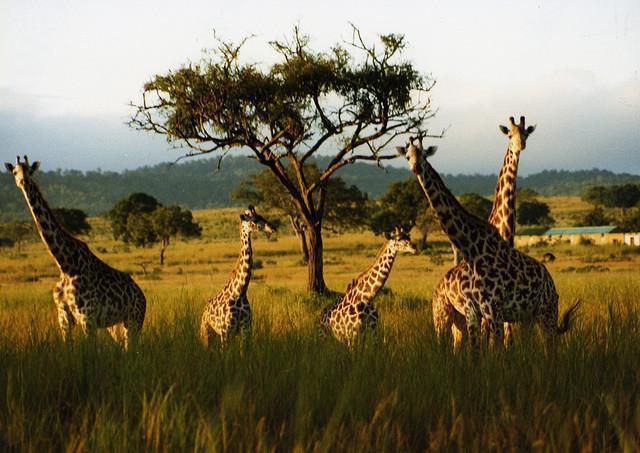How heavy is a newborn giraffe calf in general?
Select the accurate answer and provide explanation: 'Answer: answer
Rationale: rationale.'
Options: 100 kg, 70 kg, 80 kg, 60 kg. Answer: 100 kg.
Rationale: Depends on their size. 